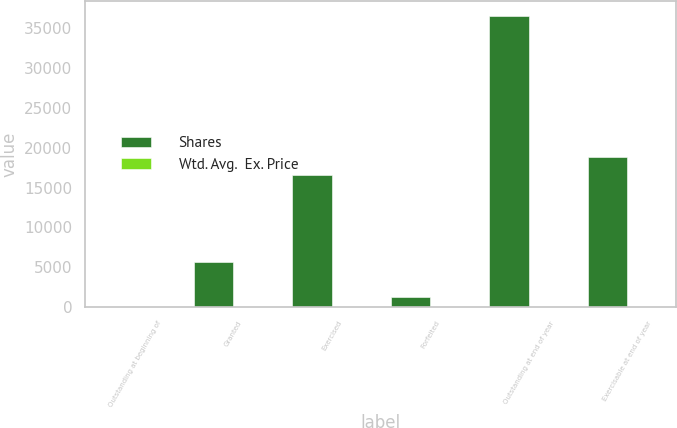Convert chart to OTSL. <chart><loc_0><loc_0><loc_500><loc_500><stacked_bar_chart><ecel><fcel>Outstanding at beginning of<fcel>Granted<fcel>Exercised<fcel>Forfeited<fcel>Outstanding at end of year<fcel>Exercisable at end of year<nl><fcel>Shares<fcel>11.76<fcel>5626<fcel>16625<fcel>1273<fcel>36579<fcel>18885<nl><fcel>Wtd. Avg.  Ex. Price<fcel>4.94<fcel>11.76<fcel>3.87<fcel>3.79<fcel>6.45<fcel>5.22<nl></chart> 